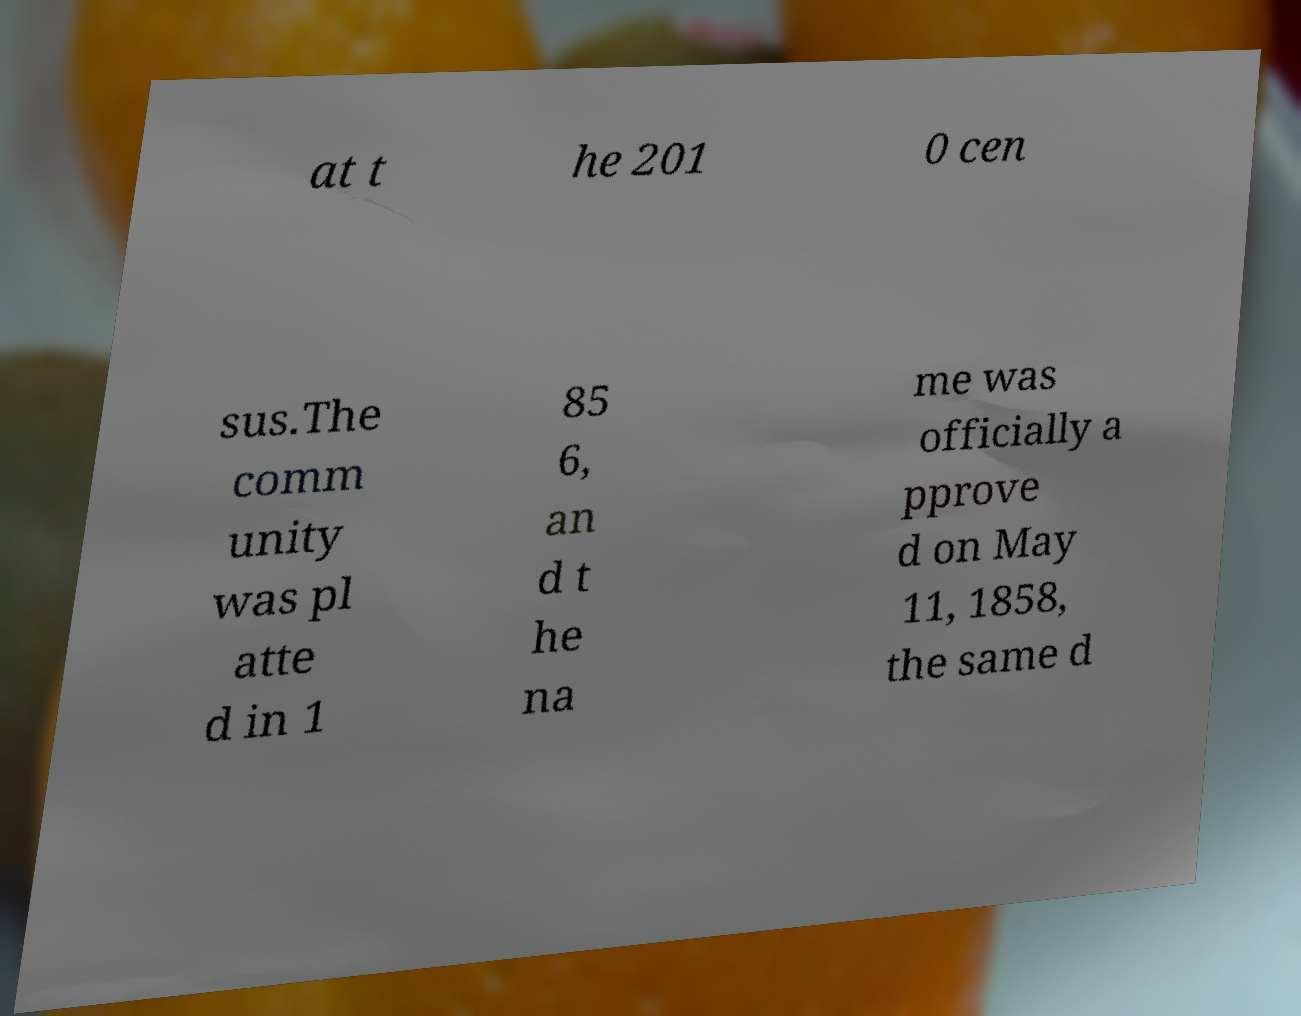There's text embedded in this image that I need extracted. Can you transcribe it verbatim? at t he 201 0 cen sus.The comm unity was pl atte d in 1 85 6, an d t he na me was officially a pprove d on May 11, 1858, the same d 